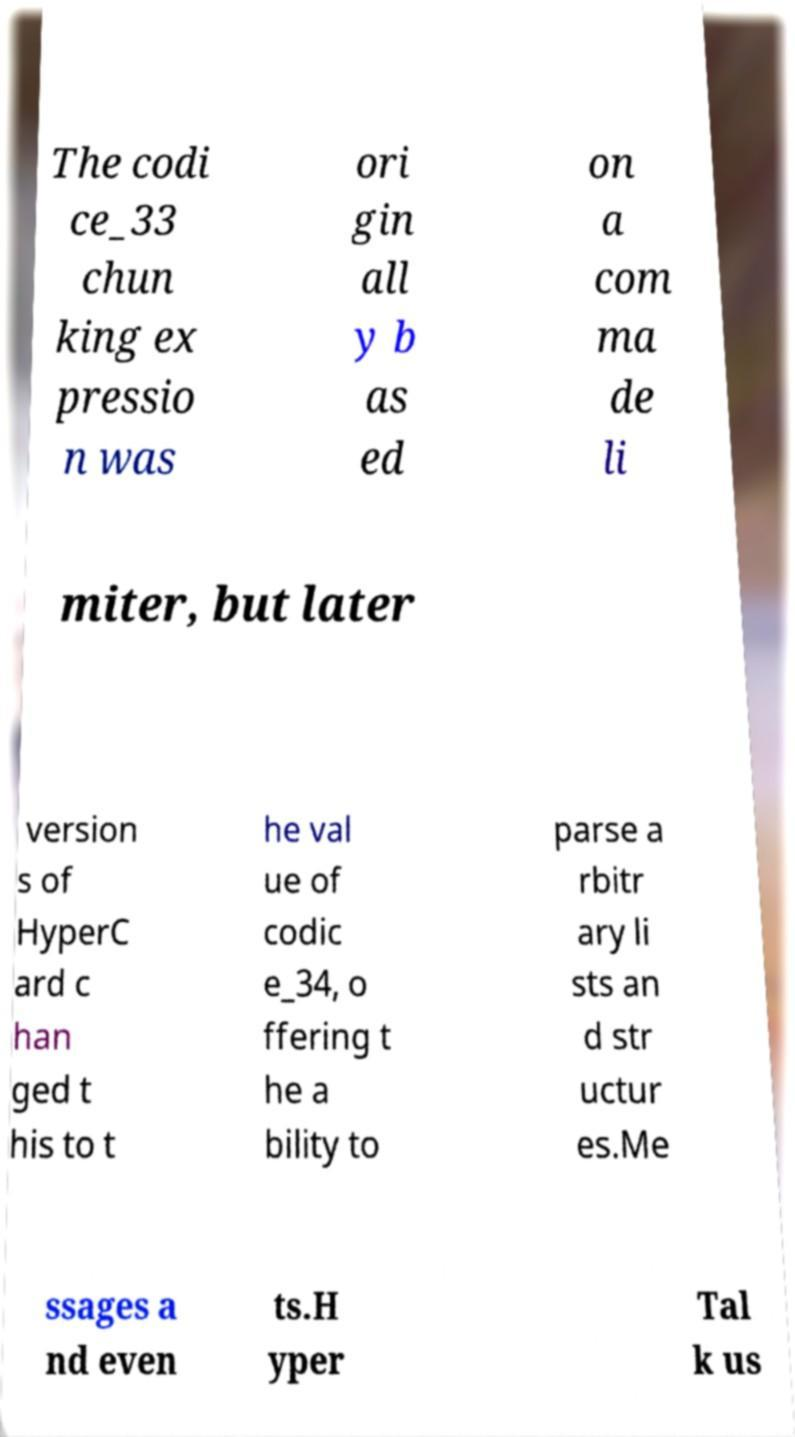I need the written content from this picture converted into text. Can you do that? The codi ce_33 chun king ex pressio n was ori gin all y b as ed on a com ma de li miter, but later version s of HyperC ard c han ged t his to t he val ue of codic e_34, o ffering t he a bility to parse a rbitr ary li sts an d str uctur es.Me ssages a nd even ts.H yper Tal k us 